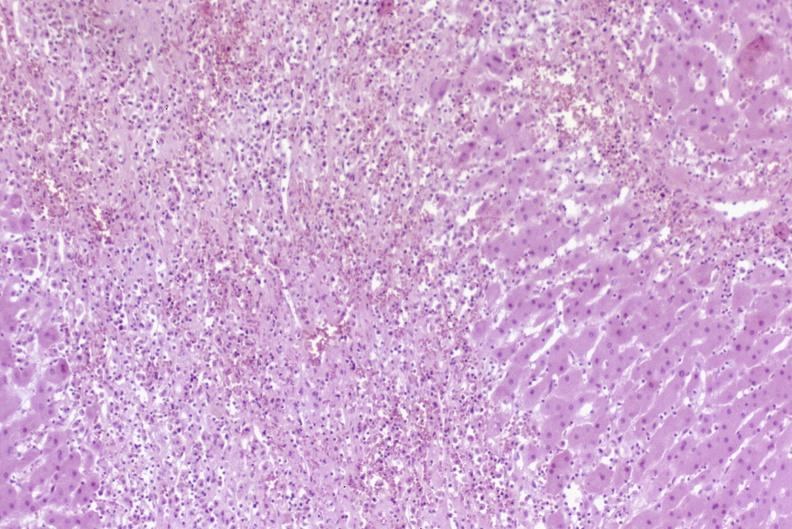does granulosa cell tumor show severe acute rejection?
Answer the question using a single word or phrase. No 